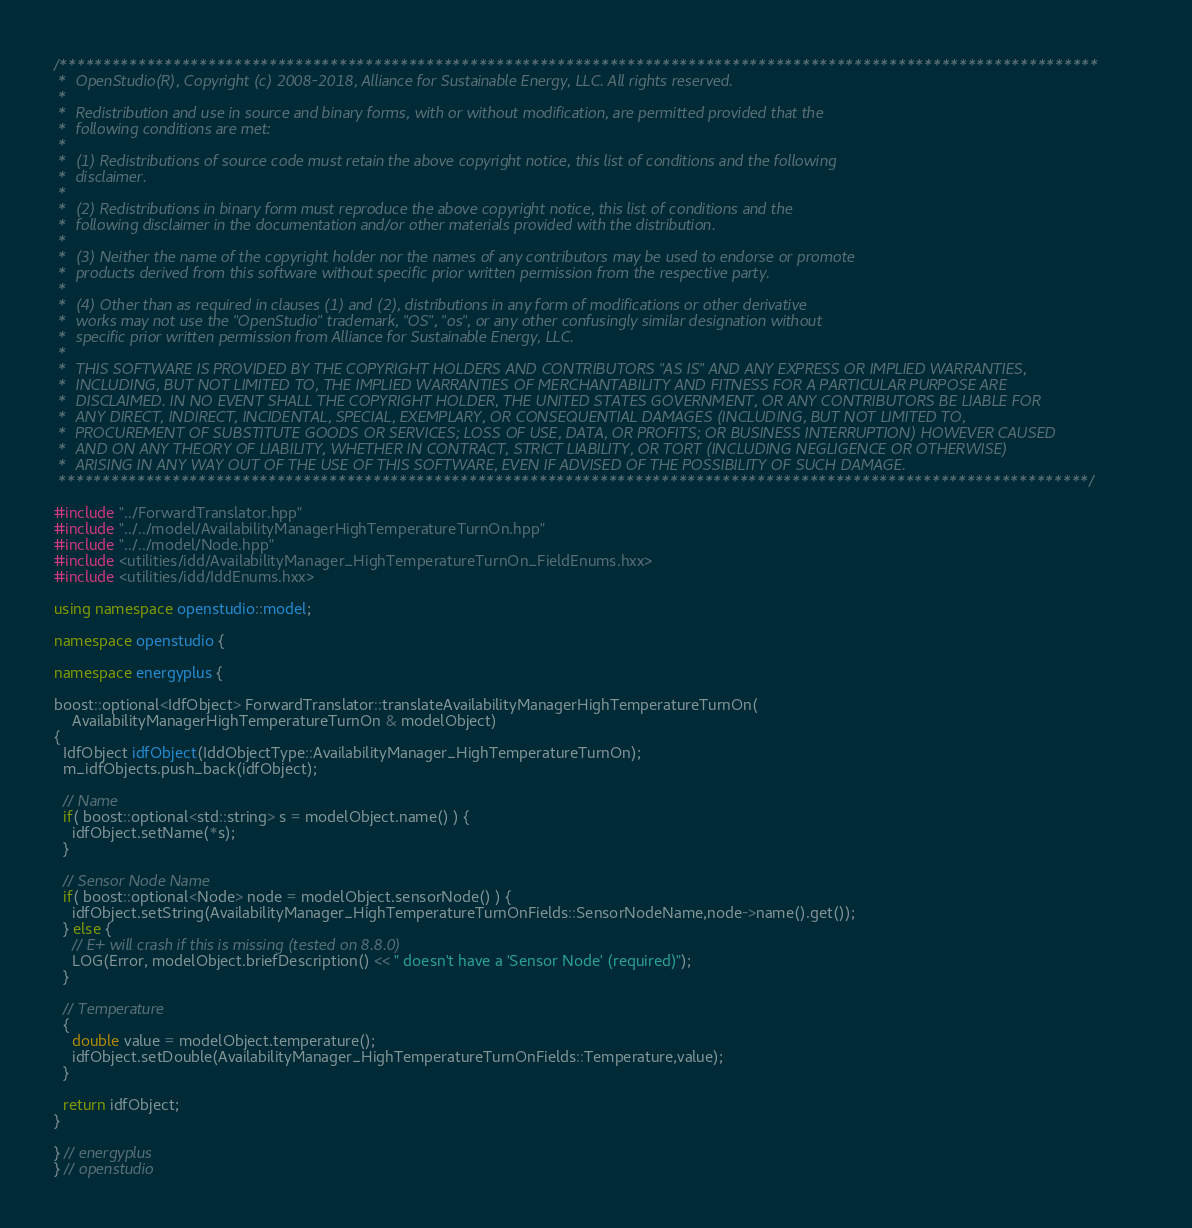Convert code to text. <code><loc_0><loc_0><loc_500><loc_500><_C++_>/***********************************************************************************************************************
 *  OpenStudio(R), Copyright (c) 2008-2018, Alliance for Sustainable Energy, LLC. All rights reserved.
 *
 *  Redistribution and use in source and binary forms, with or without modification, are permitted provided that the
 *  following conditions are met:
 *
 *  (1) Redistributions of source code must retain the above copyright notice, this list of conditions and the following
 *  disclaimer.
 *
 *  (2) Redistributions in binary form must reproduce the above copyright notice, this list of conditions and the
 *  following disclaimer in the documentation and/or other materials provided with the distribution.
 *
 *  (3) Neither the name of the copyright holder nor the names of any contributors may be used to endorse or promote
 *  products derived from this software without specific prior written permission from the respective party.
 *
 *  (4) Other than as required in clauses (1) and (2), distributions in any form of modifications or other derivative
 *  works may not use the "OpenStudio" trademark, "OS", "os", or any other confusingly similar designation without
 *  specific prior written permission from Alliance for Sustainable Energy, LLC.
 *
 *  THIS SOFTWARE IS PROVIDED BY THE COPYRIGHT HOLDERS AND CONTRIBUTORS "AS IS" AND ANY EXPRESS OR IMPLIED WARRANTIES,
 *  INCLUDING, BUT NOT LIMITED TO, THE IMPLIED WARRANTIES OF MERCHANTABILITY AND FITNESS FOR A PARTICULAR PURPOSE ARE
 *  DISCLAIMED. IN NO EVENT SHALL THE COPYRIGHT HOLDER, THE UNITED STATES GOVERNMENT, OR ANY CONTRIBUTORS BE LIABLE FOR
 *  ANY DIRECT, INDIRECT, INCIDENTAL, SPECIAL, EXEMPLARY, OR CONSEQUENTIAL DAMAGES (INCLUDING, BUT NOT LIMITED TO,
 *  PROCUREMENT OF SUBSTITUTE GOODS OR SERVICES; LOSS OF USE, DATA, OR PROFITS; OR BUSINESS INTERRUPTION) HOWEVER CAUSED
 *  AND ON ANY THEORY OF LIABILITY, WHETHER IN CONTRACT, STRICT LIABILITY, OR TORT (INCLUDING NEGLIGENCE OR OTHERWISE)
 *  ARISING IN ANY WAY OUT OF THE USE OF THIS SOFTWARE, EVEN IF ADVISED OF THE POSSIBILITY OF SUCH DAMAGE.
 **********************************************************************************************************************/

#include "../ForwardTranslator.hpp"
#include "../../model/AvailabilityManagerHighTemperatureTurnOn.hpp"
#include "../../model/Node.hpp"
#include <utilities/idd/AvailabilityManager_HighTemperatureTurnOn_FieldEnums.hxx>
#include <utilities/idd/IddEnums.hxx>

using namespace openstudio::model;

namespace openstudio {

namespace energyplus {

boost::optional<IdfObject> ForwardTranslator::translateAvailabilityManagerHighTemperatureTurnOn(
    AvailabilityManagerHighTemperatureTurnOn & modelObject)
{
  IdfObject idfObject(IddObjectType::AvailabilityManager_HighTemperatureTurnOn);
  m_idfObjects.push_back(idfObject);

  // Name
  if( boost::optional<std::string> s = modelObject.name() ) {
    idfObject.setName(*s);
  }

  // Sensor Node Name
  if( boost::optional<Node> node = modelObject.sensorNode() ) {
    idfObject.setString(AvailabilityManager_HighTemperatureTurnOnFields::SensorNodeName,node->name().get());
  } else {
    // E+ will crash if this is missing (tested on 8.8.0)
    LOG(Error, modelObject.briefDescription() << " doesn't have a 'Sensor Node' (required)");
  }

  // Temperature
  {
    double value = modelObject.temperature();
    idfObject.setDouble(AvailabilityManager_HighTemperatureTurnOnFields::Temperature,value);
  }

  return idfObject;
}

} // energyplus
} // openstudio
</code> 